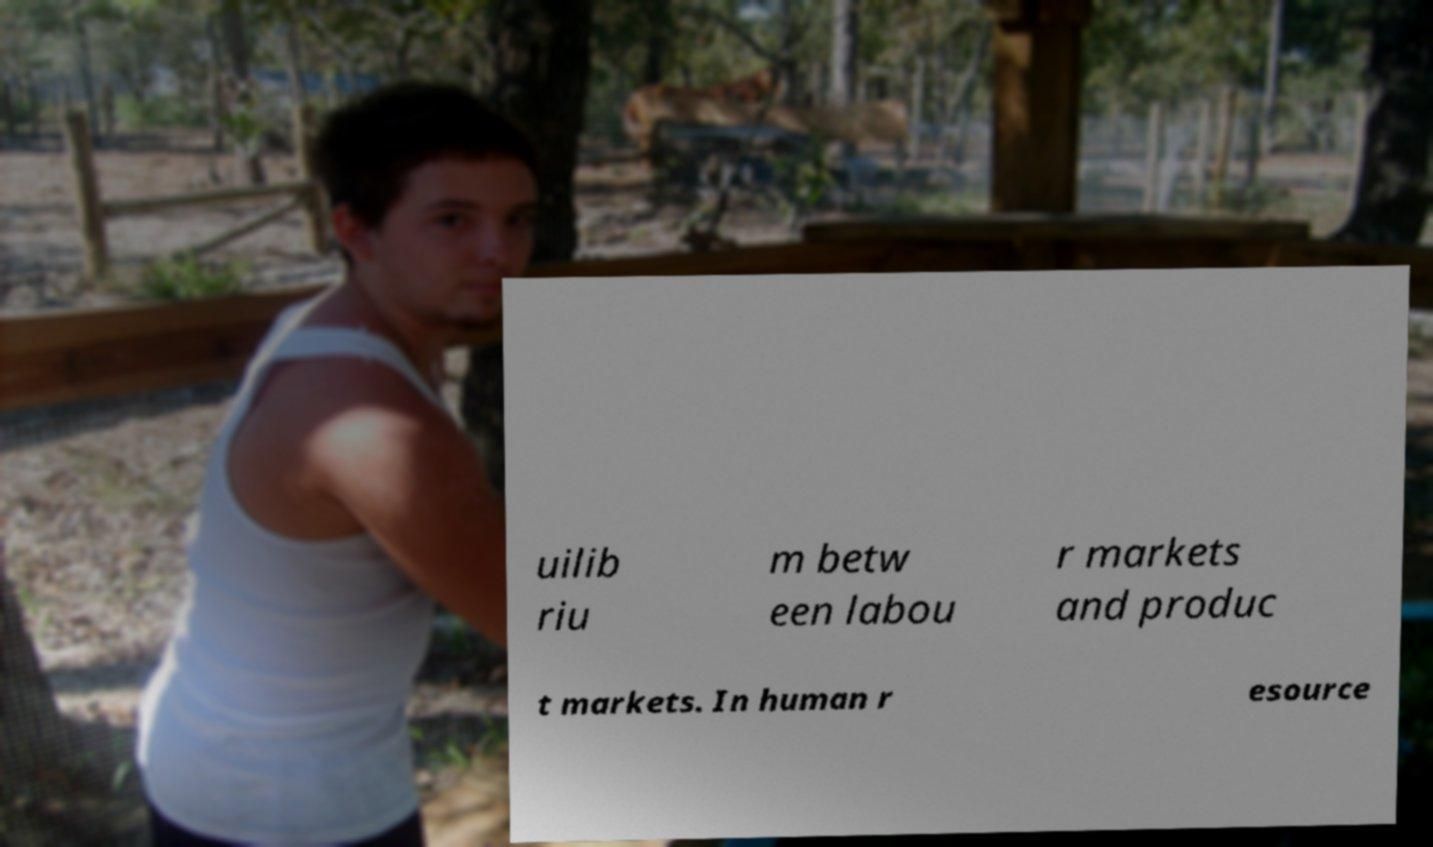For documentation purposes, I need the text within this image transcribed. Could you provide that? uilib riu m betw een labou r markets and produc t markets. In human r esource 